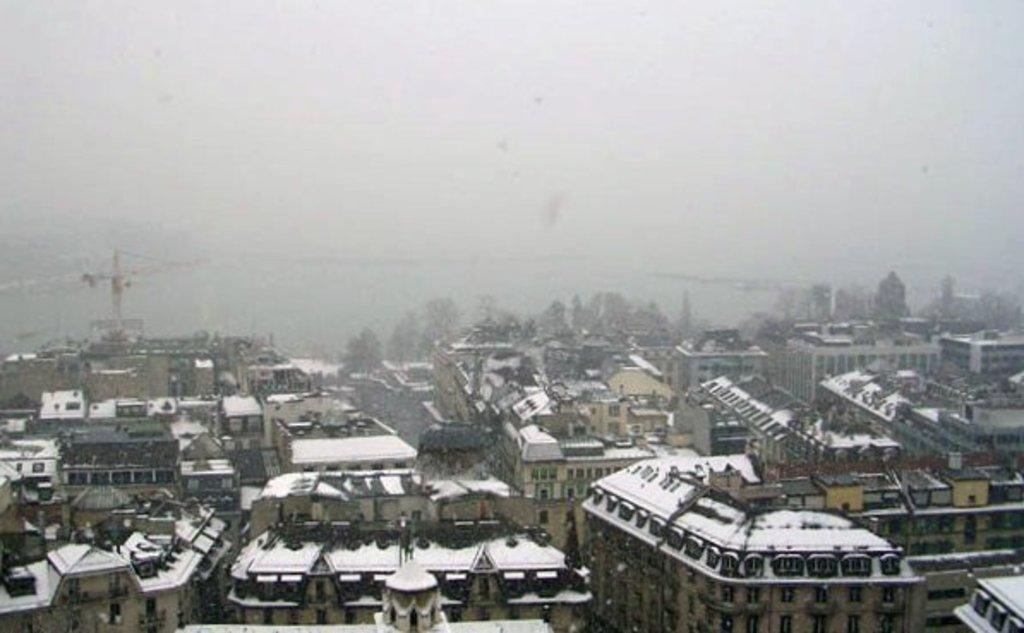What type of view is shown in the image? The image is a top view of a city. How are the buildings in the city depicted? The buildings in the city are covered under snow. How many cast members can be seen in the image? There are no cast members present in the image, as it is a top view of a city with buildings covered in snow. What type of snakes can be seen slithering through the streets in the image? There are no snakes visible in the image; it is a top view of a city with buildings covered in snow. 